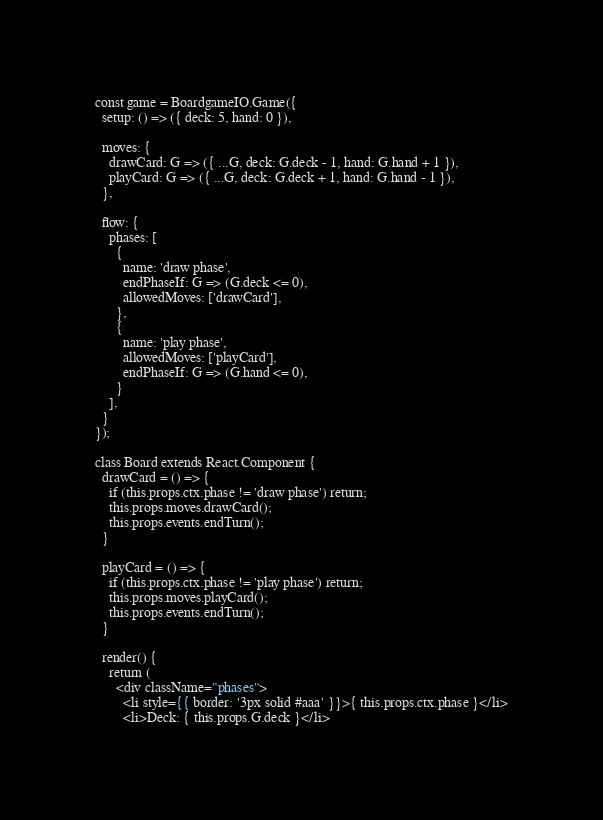<code> <loc_0><loc_0><loc_500><loc_500><_HTML_>const game = BoardgameIO.Game({
  setup: () => ({ deck: 5, hand: 0 }),

  moves: {
    drawCard: G => ({ ...G, deck: G.deck - 1, hand: G.hand + 1 }),
    playCard: G => ({ ...G, deck: G.deck + 1, hand: G.hand - 1 }),
  },

  flow: {
    phases: [
      {
        name: 'draw phase',
        endPhaseIf: G => (G.deck <= 0),
        allowedMoves: ['drawCard'],
      },
      {
        name: 'play phase',
        allowedMoves: ['playCard'],
        endPhaseIf: G => (G.hand <= 0),
      }
    ],
  }
});

class Board extends React.Component {
  drawCard = () => {
    if (this.props.ctx.phase != 'draw phase') return;
    this.props.moves.drawCard();
    this.props.events.endTurn();
  }

  playCard = () => {
    if (this.props.ctx.phase != 'play phase') return;
    this.props.moves.playCard();
    this.props.events.endTurn();
  }

  render() {
    return (
      <div className="phases">
        <li style={{ border: '3px solid #aaa' }}>{ this.props.ctx.phase }</li>
        <li>Deck: { this.props.G.deck }</li></code> 